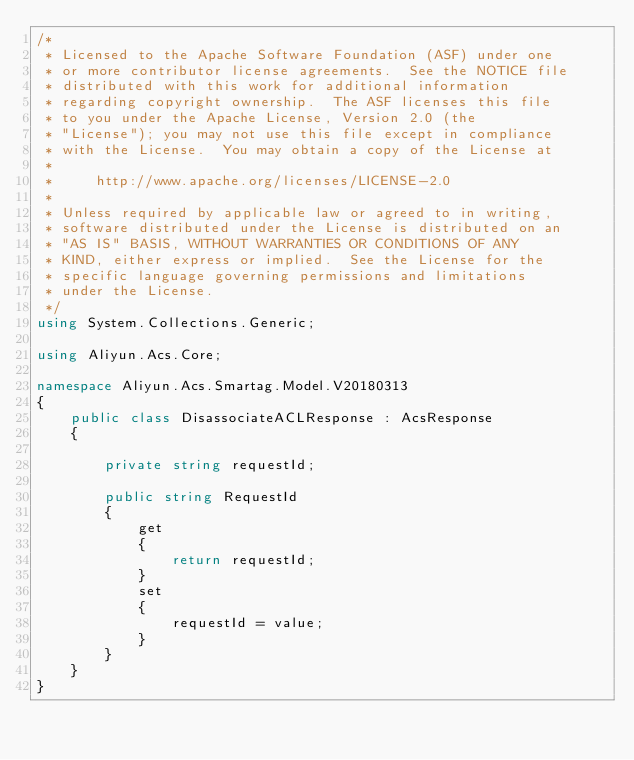<code> <loc_0><loc_0><loc_500><loc_500><_C#_>/*
 * Licensed to the Apache Software Foundation (ASF) under one
 * or more contributor license agreements.  See the NOTICE file
 * distributed with this work for additional information
 * regarding copyright ownership.  The ASF licenses this file
 * to you under the Apache License, Version 2.0 (the
 * "License"); you may not use this file except in compliance
 * with the License.  You may obtain a copy of the License at
 *
 *     http://www.apache.org/licenses/LICENSE-2.0
 *
 * Unless required by applicable law or agreed to in writing,
 * software distributed under the License is distributed on an
 * "AS IS" BASIS, WITHOUT WARRANTIES OR CONDITIONS OF ANY
 * KIND, either express or implied.  See the License for the
 * specific language governing permissions and limitations
 * under the License.
 */
using System.Collections.Generic;

using Aliyun.Acs.Core;

namespace Aliyun.Acs.Smartag.Model.V20180313
{
	public class DisassociateACLResponse : AcsResponse
	{

		private string requestId;

		public string RequestId
		{
			get
			{
				return requestId;
			}
			set	
			{
				requestId = value;
			}
		}
	}
}
</code> 